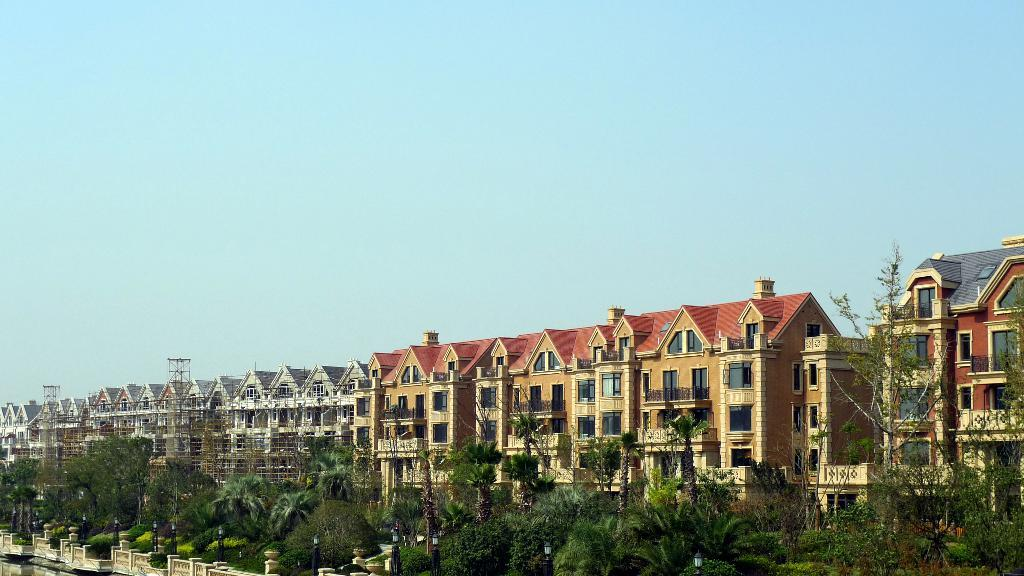What type of vegetation can be seen in the image? There are trees in the image. What type of structures are present in the image? There are buildings in the image. What is the purpose of the barrier visible in the image? There is a fence in the image, which serves as a barrier. What can be seen at the left side of the image? There is water visible at the left side of the image. Can you see a zebra playing with a net in the image? There is no zebra or net present in the image. What type of material is used to make the cork in the image? There is no cork present in the image. 